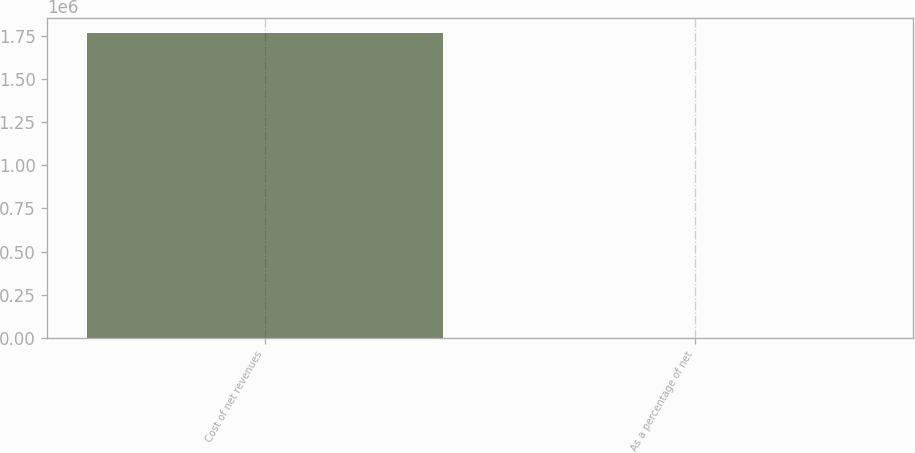Convert chart to OTSL. <chart><loc_0><loc_0><loc_500><loc_500><bar_chart><fcel>Cost of net revenues<fcel>As a percentage of net<nl><fcel>1.76297e+06<fcel>23<nl></chart> 